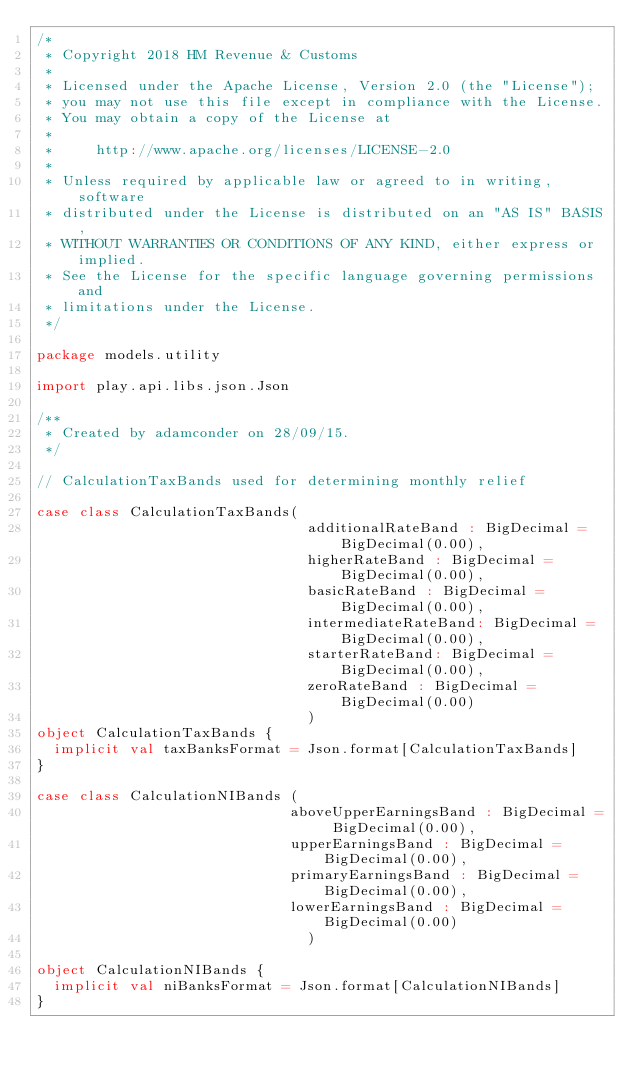Convert code to text. <code><loc_0><loc_0><loc_500><loc_500><_Scala_>/*
 * Copyright 2018 HM Revenue & Customs
 *
 * Licensed under the Apache License, Version 2.0 (the "License");
 * you may not use this file except in compliance with the License.
 * You may obtain a copy of the License at
 *
 *     http://www.apache.org/licenses/LICENSE-2.0
 *
 * Unless required by applicable law or agreed to in writing, software
 * distributed under the License is distributed on an "AS IS" BASIS,
 * WITHOUT WARRANTIES OR CONDITIONS OF ANY KIND, either express or implied.
 * See the License for the specific language governing permissions and
 * limitations under the License.
 */

package models.utility

import play.api.libs.json.Json

/**
 * Created by adamconder on 28/09/15.
 */

// CalculationTaxBands used for determining monthly relief

case class CalculationTaxBands(
                                additionalRateBand : BigDecimal = BigDecimal(0.00),
                                higherRateBand : BigDecimal = BigDecimal(0.00),
                                basicRateBand : BigDecimal = BigDecimal(0.00),
                                intermediateRateBand: BigDecimal = BigDecimal(0.00),
                                starterRateBand: BigDecimal = BigDecimal(0.00),
                                zeroRateBand : BigDecimal = BigDecimal(0.00)
                                )
object CalculationTaxBands {
  implicit val taxBanksFormat = Json.format[CalculationTaxBands]
}

case class CalculationNIBands (
                              aboveUpperEarningsBand : BigDecimal = BigDecimal(0.00),
                              upperEarningsBand : BigDecimal = BigDecimal(0.00),
                              primaryEarningsBand : BigDecimal = BigDecimal(0.00),
                              lowerEarningsBand : BigDecimal = BigDecimal(0.00)
                                )

object CalculationNIBands {
  implicit val niBanksFormat = Json.format[CalculationNIBands]
}
</code> 